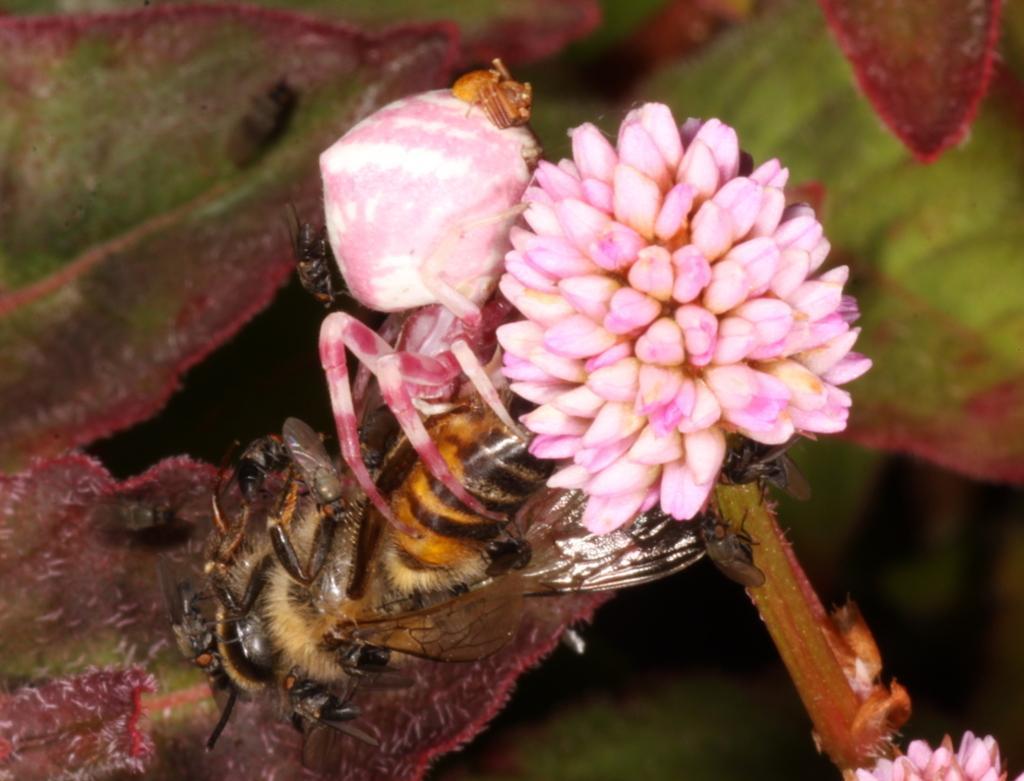Please provide a concise description of this image. In this picture we can see few flowers, a honeybee and few insects. 